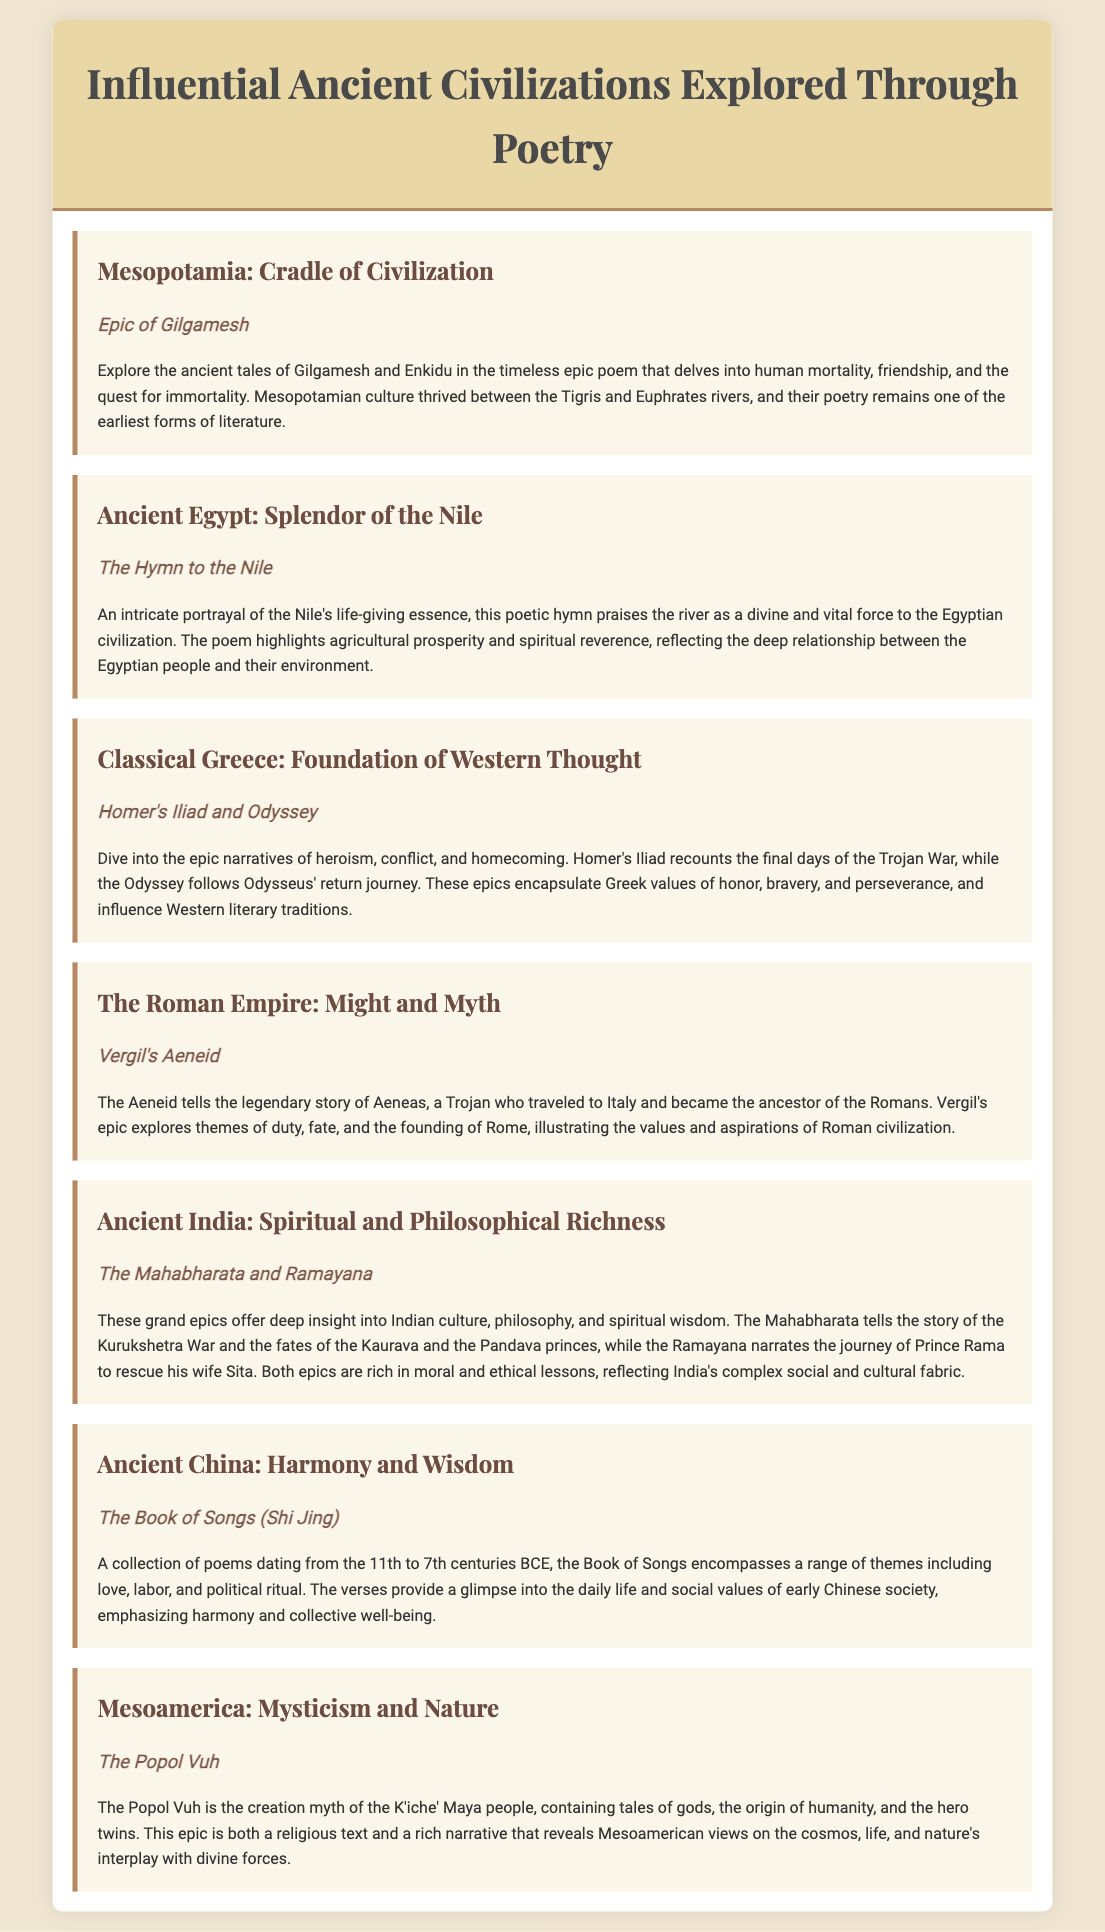What is the title of the document? The title of the document is prominently displayed at the top of the infographic.
Answer: Influential Ancient Civilizations Explored Through Poetry Which ancient civilization is associated with the Epic of Gilgamesh? The Epic of Gilgamesh is linked with the civilization mentioned directly in the corresponding section of the document.
Answer: Mesopotamia What is the main theme of The Hymn to the Nile? The main theme of The Hymn to the Nile reflects the vital role of the Nile to the Egyptian civilization, as highlighted in the description.
Answer: Life-giving essence Which two epics are associated with Ancient India? The associated epics are clearly listed in the section about Ancient India.
Answer: The Mahabharata and Ramayana What does the Aeneid explore? The Aeneid deals with themes articulated in its descriptive text within the Roman civilization section.
Answer: Duty, fate, and the founding of Rome How does the Book of Songs relate to ancient Chinese society? The relationship is described through the themes the poems cover, as noted in the Ancient China section.
Answer: Daily life and social values What civilization is linked to the Popol Vuh? The civilization associated with the Popol Vuh is directly identified in its respective section of the infographic.
Answer: Mesoamerica Which two epic narratives were written by Homer? The response is explicit in the Classical Greece section, identifying both works by their titles.
Answer: Iliad and Odyssey What river is praised in The Hymn to the Nile? The river being praised is explicitly named within the text discussing Ancient Egypt.
Answer: Nile 